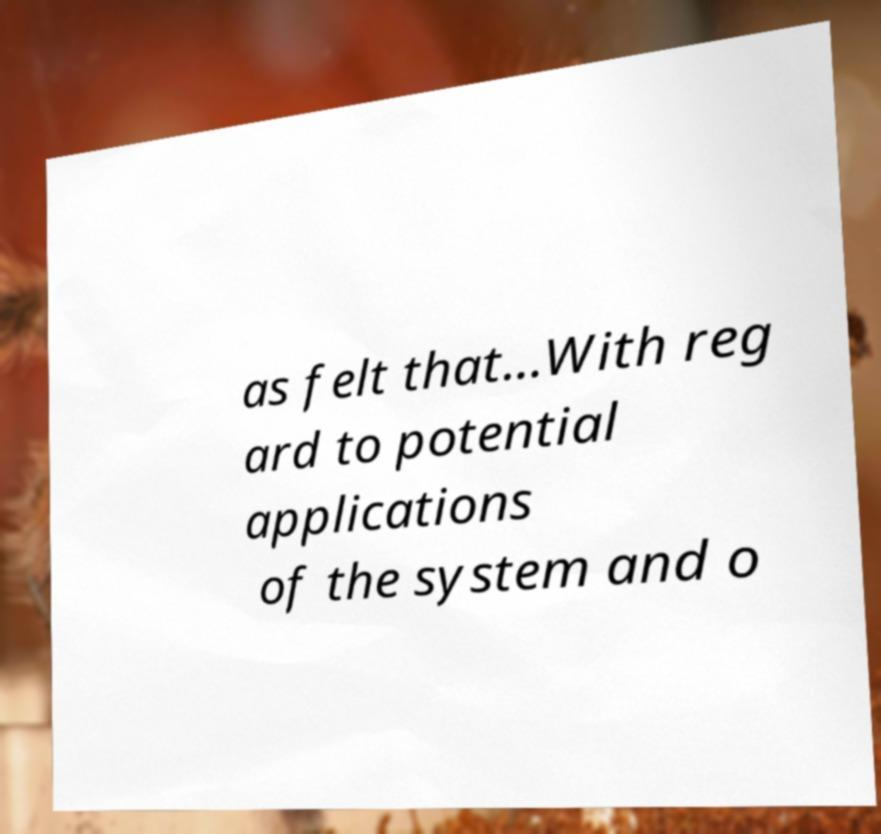What messages or text are displayed in this image? I need them in a readable, typed format. as felt that...With reg ard to potential applications of the system and o 